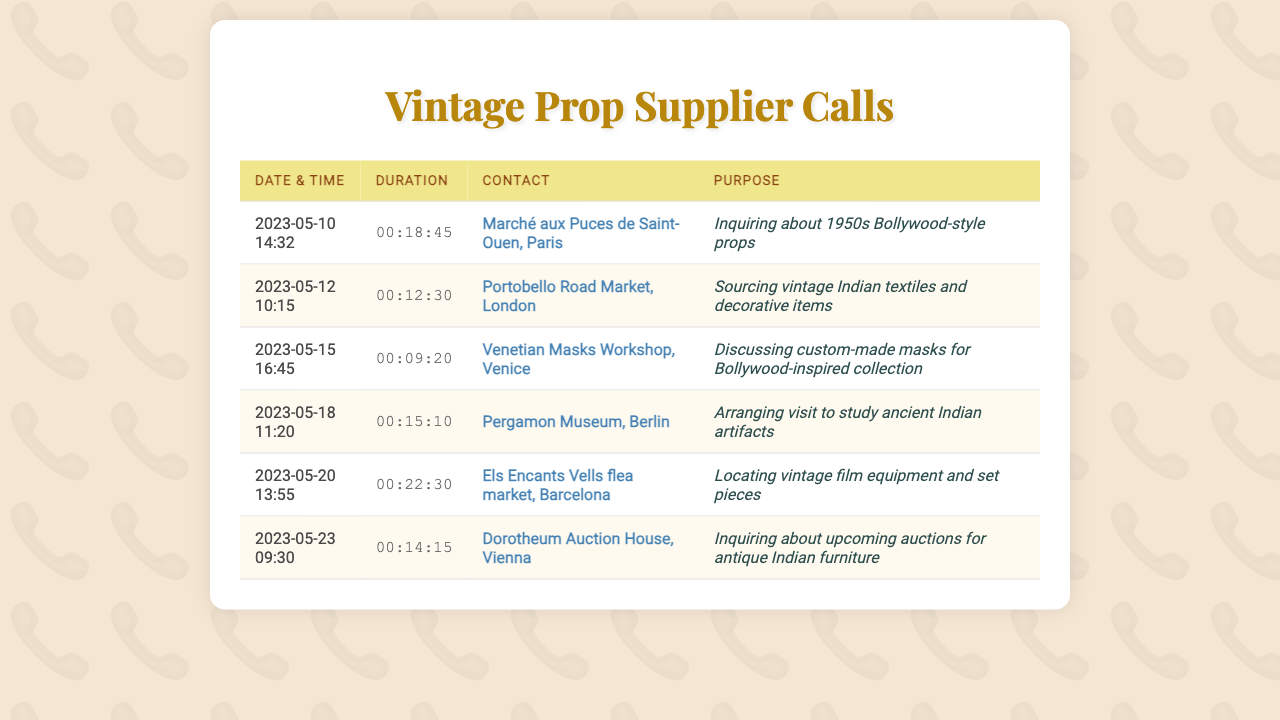what was the duration of the call on May 10, 2023? The duration of the call on May 10, 2023, is listed in the document as 00:18:45.
Answer: 00:18:45 which supplier was contacted on May 12, 2023? The document mentions the contact on May 12, 2023, as Portobello Road Market, London.
Answer: Portobello Road Market, London what was the purpose of the call on May 15, 2023? The purpose of the call on May 15, 2023, was to discuss custom-made masks for a Bollywood-inspired collection.
Answer: Discussing custom-made masks for Bollywood-inspired collection how many calls were made to suppliers located in Italy? There is one call made to a supplier located in Italy, specifically to the Venetian Masks Workshop in Venice.
Answer: 1 which contact appears at the latest date and time in the document? The latest date and time listed in the document is for the call made on May 23, 2023, to Dorotheum Auction House, Vienna.
Answer: Dorotheum Auction House, Vienna what was the initial purpose of the call on May 20, 2023? The purpose of the call on May 20, 2023, was to locate vintage film equipment and set pieces.
Answer: Locating vintage film equipment and set pieces how long was the shortest call in the records? The shortest call is on May 15, 2023, with a duration of 00:09:20.
Answer: 00:09:20 which city hosted the flea market mentioned in the calls? The flea market mentioned in the calls is located in Barcelona.
Answer: Barcelona 